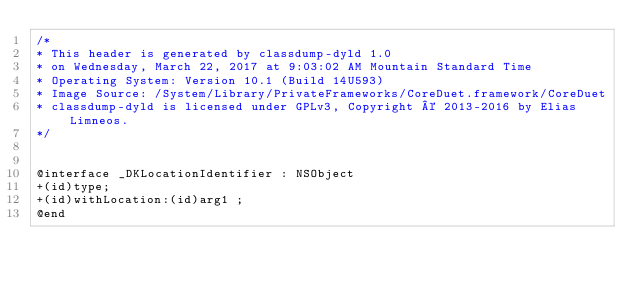Convert code to text. <code><loc_0><loc_0><loc_500><loc_500><_C_>/*
* This header is generated by classdump-dyld 1.0
* on Wednesday, March 22, 2017 at 9:03:02 AM Mountain Standard Time
* Operating System: Version 10.1 (Build 14U593)
* Image Source: /System/Library/PrivateFrameworks/CoreDuet.framework/CoreDuet
* classdump-dyld is licensed under GPLv3, Copyright © 2013-2016 by Elias Limneos.
*/


@interface _DKLocationIdentifier : NSObject
+(id)type;
+(id)withLocation:(id)arg1 ;
@end

</code> 